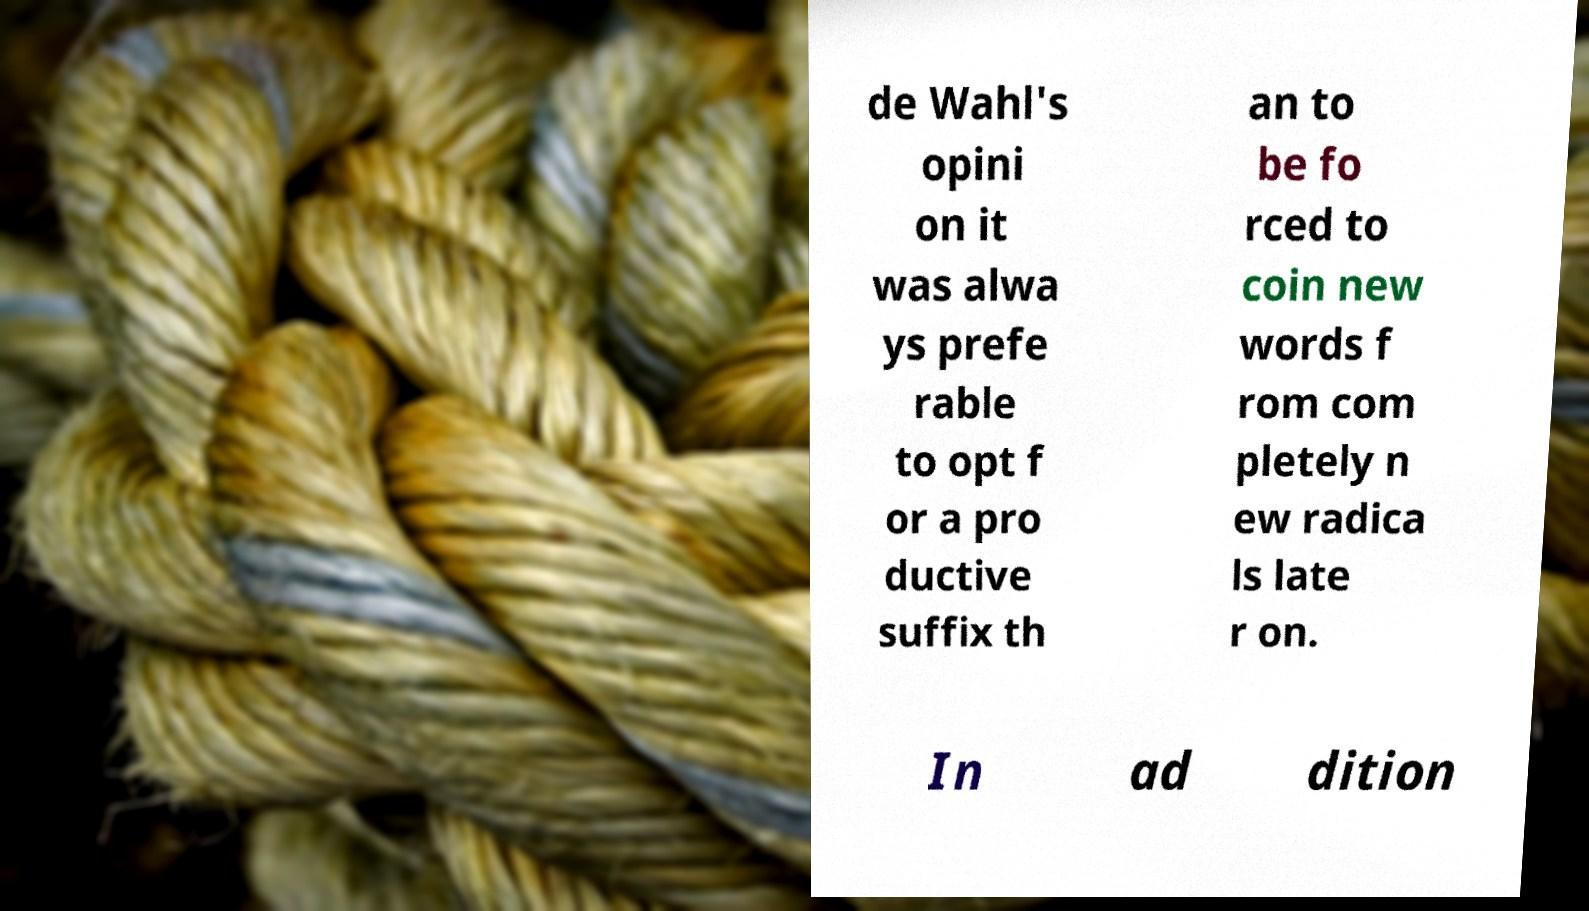Could you assist in decoding the text presented in this image and type it out clearly? de Wahl's opini on it was alwa ys prefe rable to opt f or a pro ductive suffix th an to be fo rced to coin new words f rom com pletely n ew radica ls late r on. In ad dition 